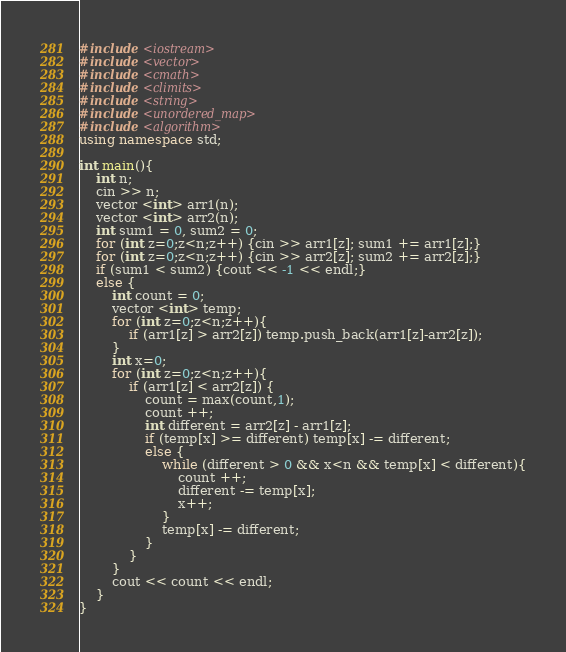<code> <loc_0><loc_0><loc_500><loc_500><_C++_>#include <iostream>
#include <vector>
#include <cmath>
#include <climits>
#include <string>
#include <unordered_map>
#include <algorithm>
using namespace std;

int main(){
	int n;
	cin >> n;
	vector <int> arr1(n);
	vector <int> arr2(n);
	int sum1 = 0, sum2 = 0;
	for (int z=0;z<n;z++) {cin >> arr1[z]; sum1 += arr1[z];}
	for (int z=0;z<n;z++) {cin >> arr2[z]; sum2 += arr2[z];}
	if (sum1 < sum2) {cout << -1 << endl;}
	else {
		int count = 0;
		vector <int> temp;
		for (int z=0;z<n;z++){
			if (arr1[z] > arr2[z]) temp.push_back(arr1[z]-arr2[z]);
		}
		int x=0;
		for (int z=0;z<n;z++){
			if (arr1[z] < arr2[z]) {
				count = max(count,1);
				count ++;
				int different = arr2[z] - arr1[z];
				if (temp[x] >= different) temp[x] -= different;
				else {
					while (different > 0 && x<n && temp[x] < different){
						count ++;
						different -= temp[x];
						x++;
					}
					temp[x] -= different;
				}
			}
		}
		cout << count << endl;
	}
}</code> 